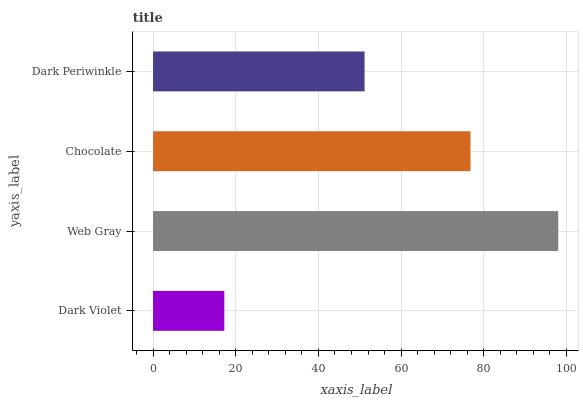Is Dark Violet the minimum?
Answer yes or no. Yes. Is Web Gray the maximum?
Answer yes or no. Yes. Is Chocolate the minimum?
Answer yes or no. No. Is Chocolate the maximum?
Answer yes or no. No. Is Web Gray greater than Chocolate?
Answer yes or no. Yes. Is Chocolate less than Web Gray?
Answer yes or no. Yes. Is Chocolate greater than Web Gray?
Answer yes or no. No. Is Web Gray less than Chocolate?
Answer yes or no. No. Is Chocolate the high median?
Answer yes or no. Yes. Is Dark Periwinkle the low median?
Answer yes or no. Yes. Is Dark Periwinkle the high median?
Answer yes or no. No. Is Dark Violet the low median?
Answer yes or no. No. 